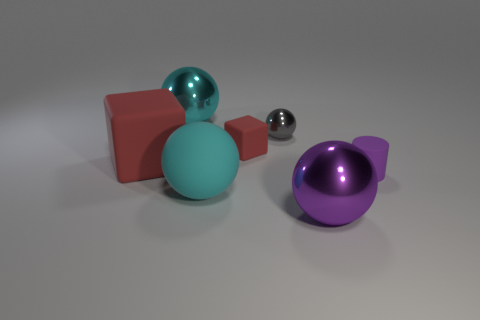There is a big cyan ball that is in front of the cylinder; how many large metallic objects are behind it?
Offer a very short reply. 1. There is a gray thing that is the same shape as the big cyan rubber thing; what material is it?
Your answer should be very brief. Metal. What is the color of the small matte block?
Your response must be concise. Red. What number of objects are gray balls or spheres?
Make the answer very short. 4. What shape is the big rubber thing to the left of the big cyan thing behind the large red object?
Offer a terse response. Cube. What number of other objects are the same material as the purple cylinder?
Offer a very short reply. 3. Does the gray sphere have the same material as the sphere that is behind the tiny metallic object?
Give a very brief answer. Yes. How many things are either tiny objects behind the small purple thing or metallic balls in front of the big matte sphere?
Your answer should be compact. 3. What number of other things are the same color as the large matte cube?
Provide a succinct answer. 1. Is the number of large objects that are on the right side of the large red thing greater than the number of tiny matte blocks that are right of the tiny gray metal ball?
Keep it short and to the point. Yes. 